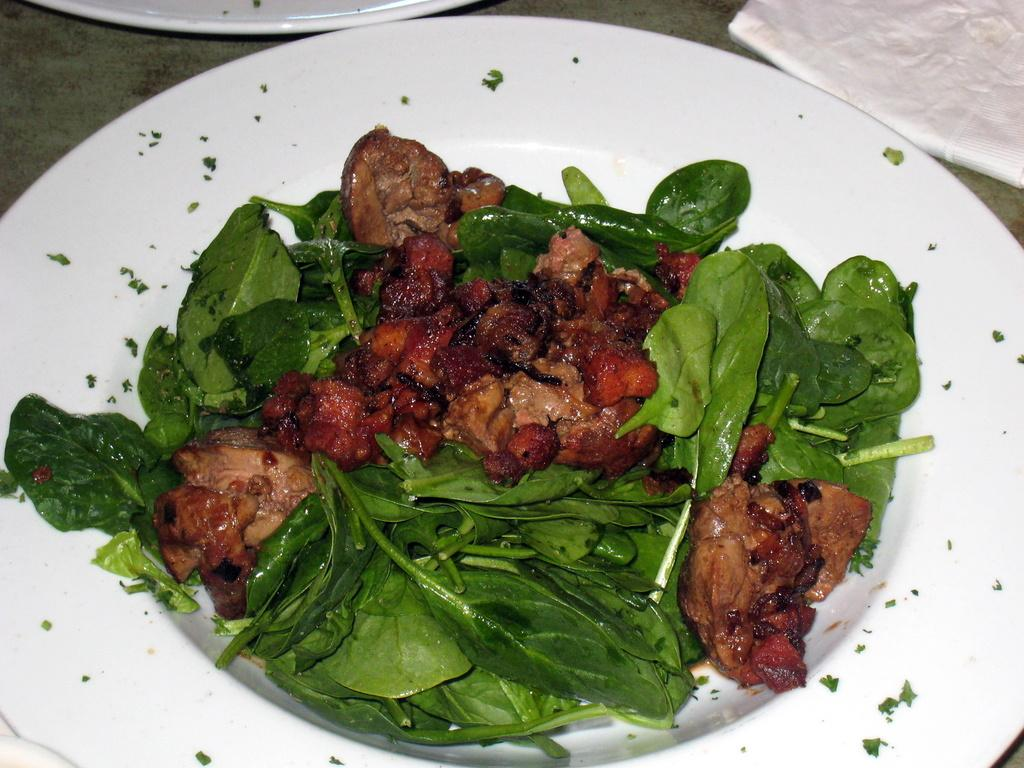What is located in the foreground of the picture? There is a plate in the foreground of the picture. What is on the plate in the foreground? The plate contains leaves and a food item. Can you describe another item visible in the image? There is a tissue paper in the image. Are there any other plates in the image? Yes, there is another plate in the image. What type of basket is visible in the image? There is no basket present in the image. What does the person in the image desire? The image does not depict a person, so it is impossible to determine their desires. 